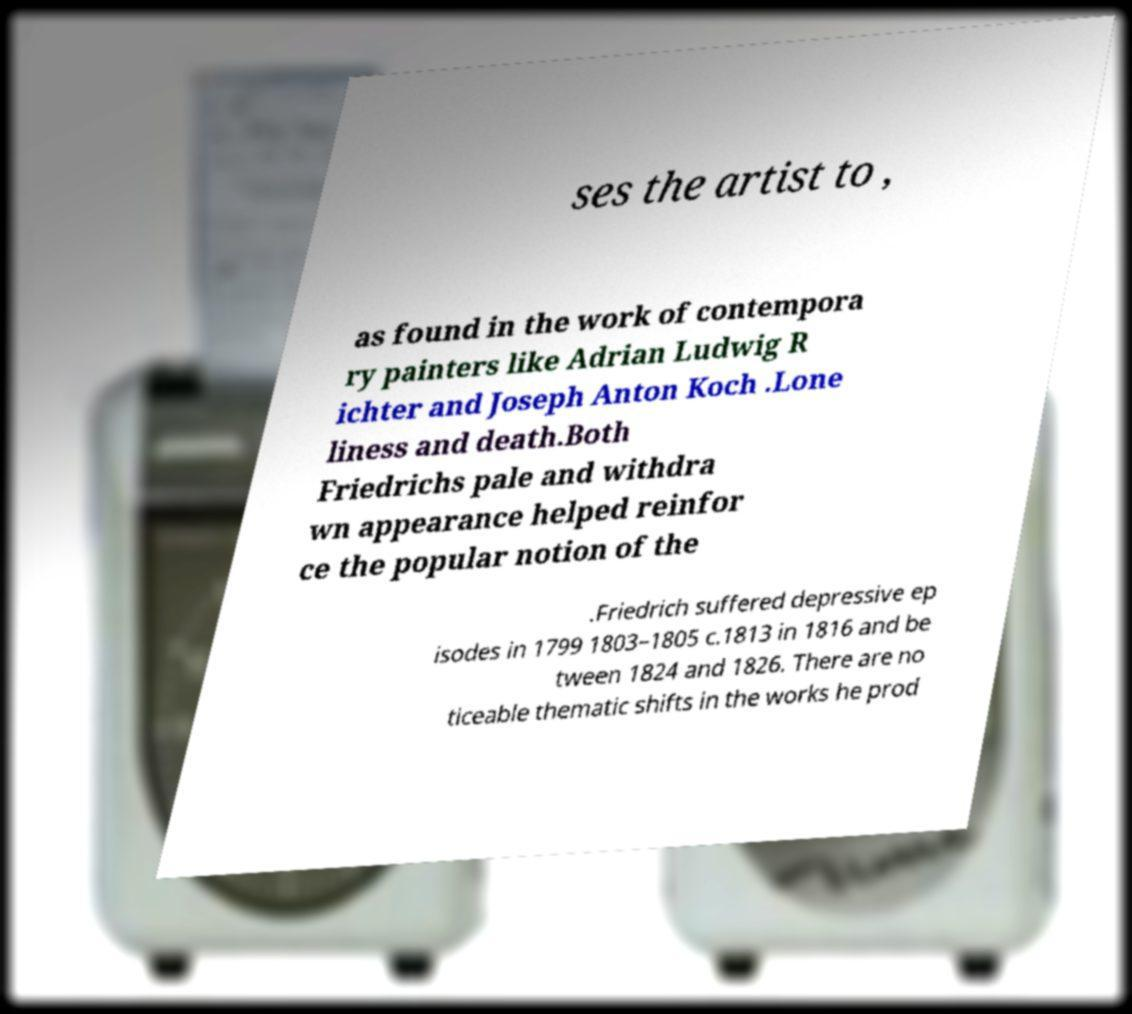What messages or text are displayed in this image? I need them in a readable, typed format. ses the artist to , as found in the work of contempora ry painters like Adrian Ludwig R ichter and Joseph Anton Koch .Lone liness and death.Both Friedrichs pale and withdra wn appearance helped reinfor ce the popular notion of the .Friedrich suffered depressive ep isodes in 1799 1803–1805 c.1813 in 1816 and be tween 1824 and 1826. There are no ticeable thematic shifts in the works he prod 